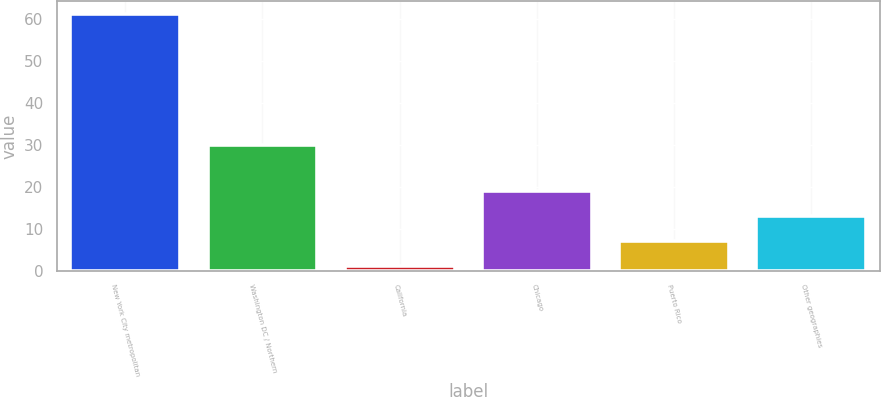Convert chart. <chart><loc_0><loc_0><loc_500><loc_500><bar_chart><fcel>New York City metropolitan<fcel>Washington DC / Northern<fcel>California<fcel>Chicago<fcel>Puerto Rico<fcel>Other geographies<nl><fcel>61<fcel>30<fcel>1<fcel>19<fcel>7<fcel>13<nl></chart> 